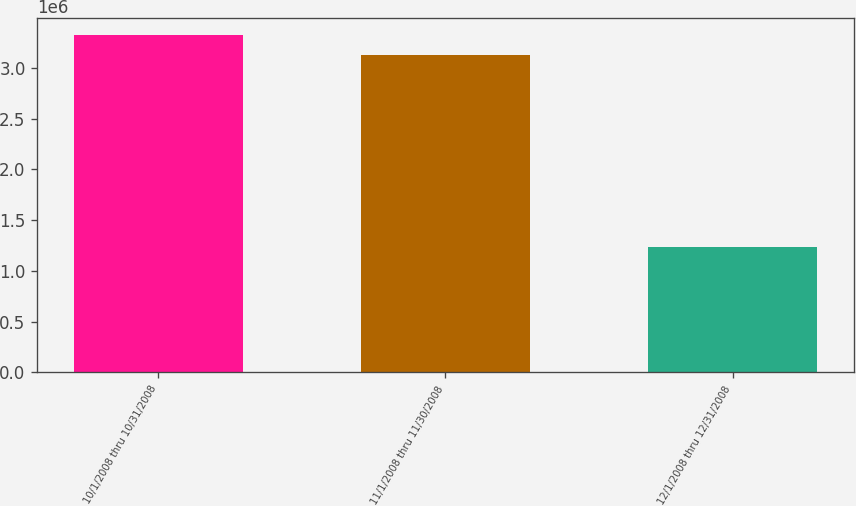Convert chart to OTSL. <chart><loc_0><loc_0><loc_500><loc_500><bar_chart><fcel>10/1/2008 thru 10/31/2008<fcel>11/1/2008 thru 11/30/2008<fcel>12/1/2008 thru 12/31/2008<nl><fcel>3.32631e+06<fcel>3.12263e+06<fcel>1.2393e+06<nl></chart> 